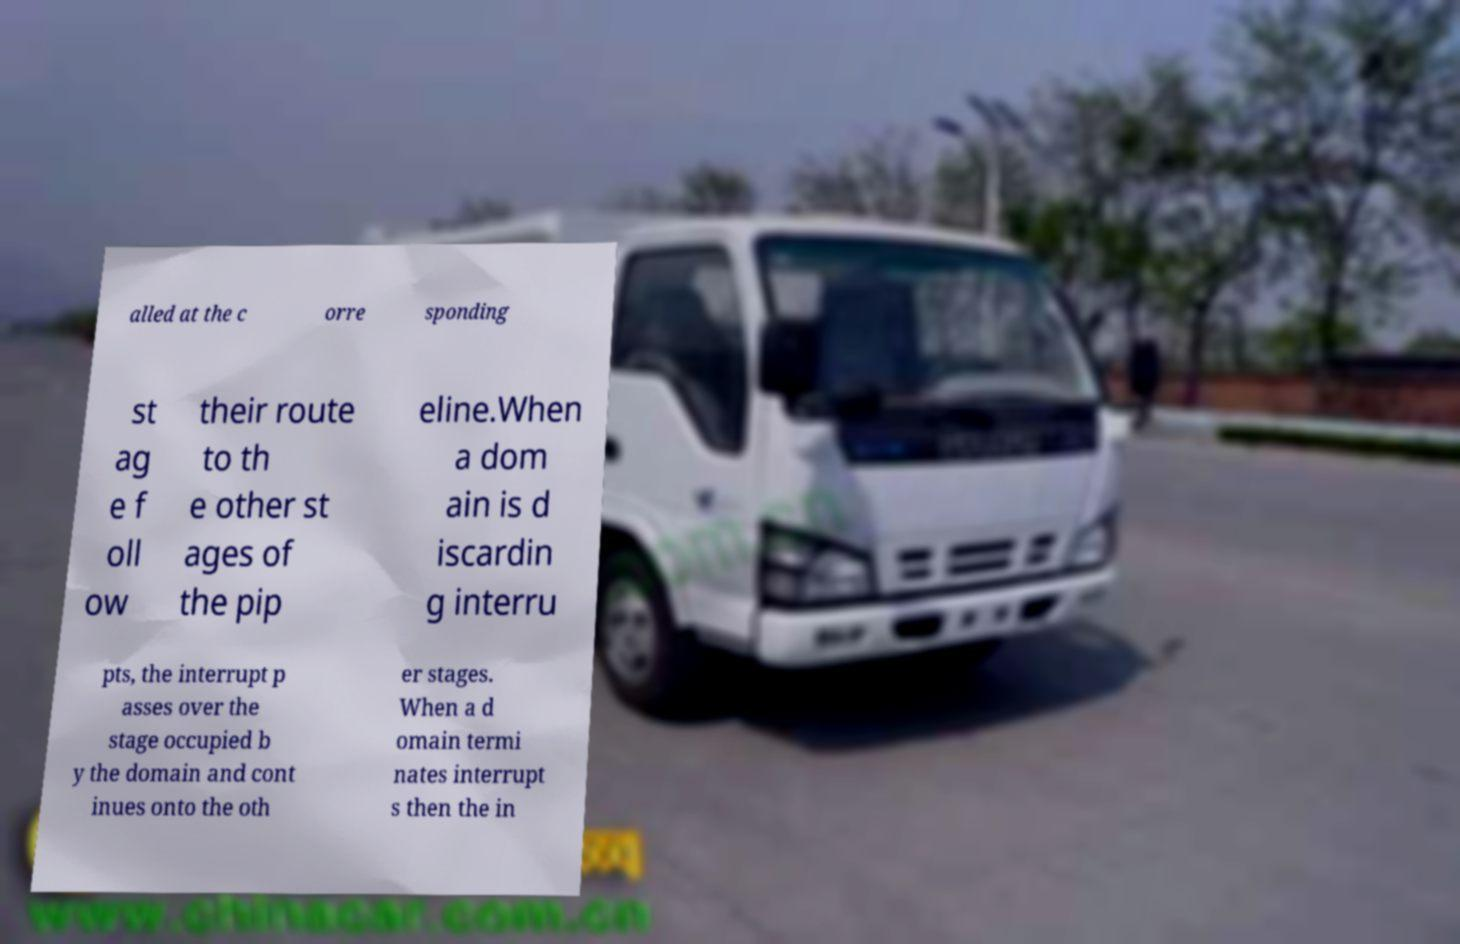Could you extract and type out the text from this image? alled at the c orre sponding st ag e f oll ow their route to th e other st ages of the pip eline.When a dom ain is d iscardin g interru pts, the interrupt p asses over the stage occupied b y the domain and cont inues onto the oth er stages. When a d omain termi nates interrupt s then the in 